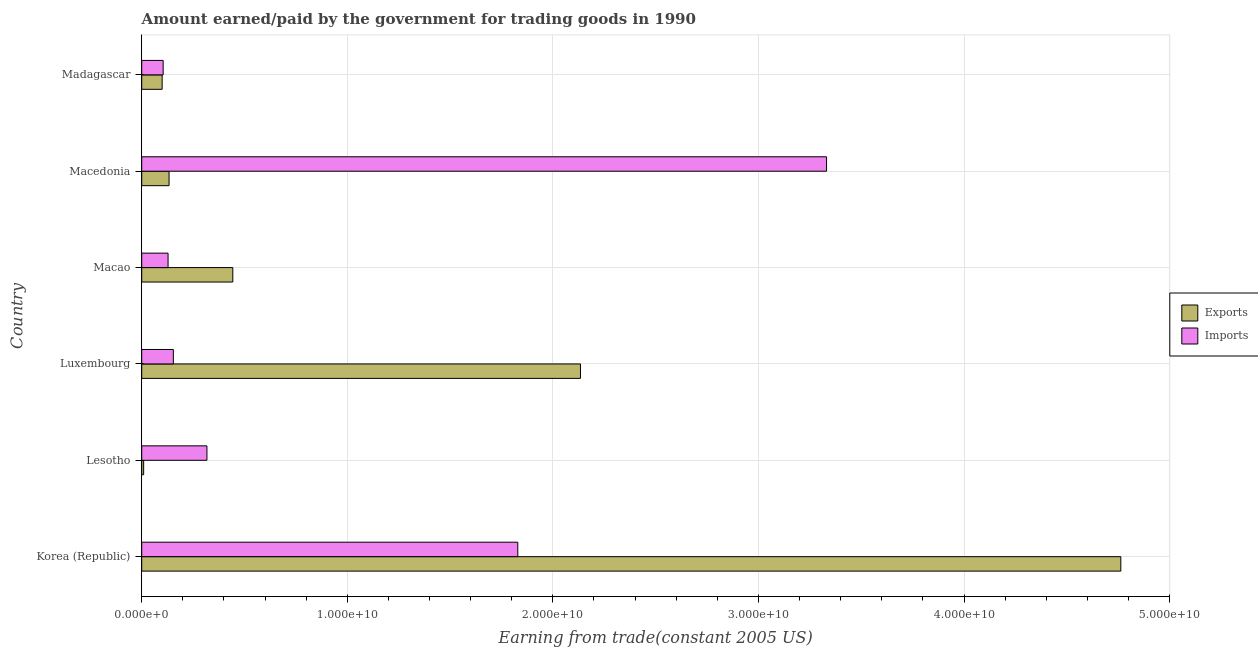How many different coloured bars are there?
Ensure brevity in your answer.  2. What is the label of the 5th group of bars from the top?
Make the answer very short. Lesotho. In how many cases, is the number of bars for a given country not equal to the number of legend labels?
Provide a short and direct response. 0. What is the amount earned from exports in Lesotho?
Offer a terse response. 9.39e+07. Across all countries, what is the maximum amount earned from exports?
Ensure brevity in your answer.  4.76e+1. Across all countries, what is the minimum amount paid for imports?
Keep it short and to the point. 1.04e+09. In which country was the amount earned from exports minimum?
Your answer should be very brief. Lesotho. What is the total amount paid for imports in the graph?
Your answer should be very brief. 5.86e+1. What is the difference between the amount paid for imports in Luxembourg and that in Macedonia?
Give a very brief answer. -3.18e+1. What is the difference between the amount paid for imports in Korea (Republic) and the amount earned from exports in Macao?
Your answer should be very brief. 1.39e+1. What is the average amount earned from exports per country?
Keep it short and to the point. 1.26e+1. What is the difference between the amount earned from exports and amount paid for imports in Luxembourg?
Offer a terse response. 1.98e+1. What is the ratio of the amount paid for imports in Lesotho to that in Macedonia?
Your response must be concise. 0.1. Is the amount paid for imports in Luxembourg less than that in Macao?
Make the answer very short. No. Is the difference between the amount earned from exports in Lesotho and Macedonia greater than the difference between the amount paid for imports in Lesotho and Macedonia?
Provide a succinct answer. Yes. What is the difference between the highest and the second highest amount earned from exports?
Offer a terse response. 2.63e+1. What is the difference between the highest and the lowest amount earned from exports?
Your response must be concise. 4.75e+1. In how many countries, is the amount earned from exports greater than the average amount earned from exports taken over all countries?
Offer a terse response. 2. Is the sum of the amount earned from exports in Lesotho and Madagascar greater than the maximum amount paid for imports across all countries?
Offer a terse response. No. What does the 1st bar from the top in Korea (Republic) represents?
Offer a very short reply. Imports. What does the 1st bar from the bottom in Madagascar represents?
Keep it short and to the point. Exports. How many countries are there in the graph?
Provide a succinct answer. 6. Are the values on the major ticks of X-axis written in scientific E-notation?
Ensure brevity in your answer.  Yes. Does the graph contain any zero values?
Give a very brief answer. No. Does the graph contain grids?
Offer a very short reply. Yes. Where does the legend appear in the graph?
Give a very brief answer. Center right. How many legend labels are there?
Your answer should be very brief. 2. How are the legend labels stacked?
Provide a succinct answer. Vertical. What is the title of the graph?
Keep it short and to the point. Amount earned/paid by the government for trading goods in 1990. What is the label or title of the X-axis?
Give a very brief answer. Earning from trade(constant 2005 US). What is the label or title of the Y-axis?
Ensure brevity in your answer.  Country. What is the Earning from trade(constant 2005 US) of Exports in Korea (Republic)?
Your answer should be very brief. 4.76e+1. What is the Earning from trade(constant 2005 US) in Imports in Korea (Republic)?
Make the answer very short. 1.83e+1. What is the Earning from trade(constant 2005 US) in Exports in Lesotho?
Ensure brevity in your answer.  9.39e+07. What is the Earning from trade(constant 2005 US) in Imports in Lesotho?
Provide a succinct answer. 3.17e+09. What is the Earning from trade(constant 2005 US) in Exports in Luxembourg?
Your answer should be very brief. 2.13e+1. What is the Earning from trade(constant 2005 US) in Imports in Luxembourg?
Your response must be concise. 1.54e+09. What is the Earning from trade(constant 2005 US) of Exports in Macao?
Your answer should be compact. 4.43e+09. What is the Earning from trade(constant 2005 US) of Imports in Macao?
Offer a very short reply. 1.28e+09. What is the Earning from trade(constant 2005 US) in Exports in Macedonia?
Make the answer very short. 1.33e+09. What is the Earning from trade(constant 2005 US) in Imports in Macedonia?
Offer a very short reply. 3.33e+1. What is the Earning from trade(constant 2005 US) of Exports in Madagascar?
Offer a terse response. 9.93e+08. What is the Earning from trade(constant 2005 US) of Imports in Madagascar?
Provide a succinct answer. 1.04e+09. Across all countries, what is the maximum Earning from trade(constant 2005 US) in Exports?
Keep it short and to the point. 4.76e+1. Across all countries, what is the maximum Earning from trade(constant 2005 US) in Imports?
Make the answer very short. 3.33e+1. Across all countries, what is the minimum Earning from trade(constant 2005 US) in Exports?
Give a very brief answer. 9.39e+07. Across all countries, what is the minimum Earning from trade(constant 2005 US) in Imports?
Offer a very short reply. 1.04e+09. What is the total Earning from trade(constant 2005 US) in Exports in the graph?
Make the answer very short. 7.58e+1. What is the total Earning from trade(constant 2005 US) in Imports in the graph?
Provide a succinct answer. 5.86e+1. What is the difference between the Earning from trade(constant 2005 US) in Exports in Korea (Republic) and that in Lesotho?
Offer a terse response. 4.75e+1. What is the difference between the Earning from trade(constant 2005 US) of Imports in Korea (Republic) and that in Lesotho?
Ensure brevity in your answer.  1.51e+1. What is the difference between the Earning from trade(constant 2005 US) in Exports in Korea (Republic) and that in Luxembourg?
Keep it short and to the point. 2.63e+1. What is the difference between the Earning from trade(constant 2005 US) in Imports in Korea (Republic) and that in Luxembourg?
Your answer should be very brief. 1.68e+1. What is the difference between the Earning from trade(constant 2005 US) of Exports in Korea (Republic) and that in Macao?
Offer a very short reply. 4.32e+1. What is the difference between the Earning from trade(constant 2005 US) of Imports in Korea (Republic) and that in Macao?
Your answer should be compact. 1.70e+1. What is the difference between the Earning from trade(constant 2005 US) of Exports in Korea (Republic) and that in Macedonia?
Offer a very short reply. 4.63e+1. What is the difference between the Earning from trade(constant 2005 US) of Imports in Korea (Republic) and that in Macedonia?
Provide a short and direct response. -1.50e+1. What is the difference between the Earning from trade(constant 2005 US) in Exports in Korea (Republic) and that in Madagascar?
Your response must be concise. 4.66e+1. What is the difference between the Earning from trade(constant 2005 US) of Imports in Korea (Republic) and that in Madagascar?
Ensure brevity in your answer.  1.73e+1. What is the difference between the Earning from trade(constant 2005 US) in Exports in Lesotho and that in Luxembourg?
Your answer should be very brief. -2.12e+1. What is the difference between the Earning from trade(constant 2005 US) of Imports in Lesotho and that in Luxembourg?
Ensure brevity in your answer.  1.63e+09. What is the difference between the Earning from trade(constant 2005 US) in Exports in Lesotho and that in Macao?
Offer a very short reply. -4.34e+09. What is the difference between the Earning from trade(constant 2005 US) of Imports in Lesotho and that in Macao?
Your answer should be very brief. 1.89e+09. What is the difference between the Earning from trade(constant 2005 US) in Exports in Lesotho and that in Macedonia?
Offer a very short reply. -1.24e+09. What is the difference between the Earning from trade(constant 2005 US) in Imports in Lesotho and that in Macedonia?
Your answer should be compact. -3.01e+1. What is the difference between the Earning from trade(constant 2005 US) in Exports in Lesotho and that in Madagascar?
Offer a terse response. -8.99e+08. What is the difference between the Earning from trade(constant 2005 US) in Imports in Lesotho and that in Madagascar?
Offer a very short reply. 2.13e+09. What is the difference between the Earning from trade(constant 2005 US) of Exports in Luxembourg and that in Macao?
Provide a short and direct response. 1.69e+1. What is the difference between the Earning from trade(constant 2005 US) of Imports in Luxembourg and that in Macao?
Offer a terse response. 2.57e+08. What is the difference between the Earning from trade(constant 2005 US) in Exports in Luxembourg and that in Macedonia?
Give a very brief answer. 2.00e+1. What is the difference between the Earning from trade(constant 2005 US) in Imports in Luxembourg and that in Macedonia?
Offer a very short reply. -3.18e+1. What is the difference between the Earning from trade(constant 2005 US) of Exports in Luxembourg and that in Madagascar?
Your answer should be compact. 2.03e+1. What is the difference between the Earning from trade(constant 2005 US) of Imports in Luxembourg and that in Madagascar?
Provide a succinct answer. 4.95e+08. What is the difference between the Earning from trade(constant 2005 US) of Exports in Macao and that in Macedonia?
Your response must be concise. 3.10e+09. What is the difference between the Earning from trade(constant 2005 US) in Imports in Macao and that in Macedonia?
Ensure brevity in your answer.  -3.20e+1. What is the difference between the Earning from trade(constant 2005 US) in Exports in Macao and that in Madagascar?
Keep it short and to the point. 3.44e+09. What is the difference between the Earning from trade(constant 2005 US) in Imports in Macao and that in Madagascar?
Keep it short and to the point. 2.39e+08. What is the difference between the Earning from trade(constant 2005 US) of Exports in Macedonia and that in Madagascar?
Give a very brief answer. 3.36e+08. What is the difference between the Earning from trade(constant 2005 US) of Imports in Macedonia and that in Madagascar?
Your answer should be compact. 3.23e+1. What is the difference between the Earning from trade(constant 2005 US) of Exports in Korea (Republic) and the Earning from trade(constant 2005 US) of Imports in Lesotho?
Ensure brevity in your answer.  4.45e+1. What is the difference between the Earning from trade(constant 2005 US) of Exports in Korea (Republic) and the Earning from trade(constant 2005 US) of Imports in Luxembourg?
Give a very brief answer. 4.61e+1. What is the difference between the Earning from trade(constant 2005 US) in Exports in Korea (Republic) and the Earning from trade(constant 2005 US) in Imports in Macao?
Make the answer very short. 4.63e+1. What is the difference between the Earning from trade(constant 2005 US) of Exports in Korea (Republic) and the Earning from trade(constant 2005 US) of Imports in Macedonia?
Offer a very short reply. 1.43e+1. What is the difference between the Earning from trade(constant 2005 US) of Exports in Korea (Republic) and the Earning from trade(constant 2005 US) of Imports in Madagascar?
Offer a very short reply. 4.66e+1. What is the difference between the Earning from trade(constant 2005 US) of Exports in Lesotho and the Earning from trade(constant 2005 US) of Imports in Luxembourg?
Give a very brief answer. -1.44e+09. What is the difference between the Earning from trade(constant 2005 US) in Exports in Lesotho and the Earning from trade(constant 2005 US) in Imports in Macao?
Your response must be concise. -1.19e+09. What is the difference between the Earning from trade(constant 2005 US) of Exports in Lesotho and the Earning from trade(constant 2005 US) of Imports in Macedonia?
Offer a terse response. -3.32e+1. What is the difference between the Earning from trade(constant 2005 US) of Exports in Lesotho and the Earning from trade(constant 2005 US) of Imports in Madagascar?
Ensure brevity in your answer.  -9.49e+08. What is the difference between the Earning from trade(constant 2005 US) of Exports in Luxembourg and the Earning from trade(constant 2005 US) of Imports in Macao?
Keep it short and to the point. 2.01e+1. What is the difference between the Earning from trade(constant 2005 US) of Exports in Luxembourg and the Earning from trade(constant 2005 US) of Imports in Macedonia?
Provide a short and direct response. -1.20e+1. What is the difference between the Earning from trade(constant 2005 US) of Exports in Luxembourg and the Earning from trade(constant 2005 US) of Imports in Madagascar?
Give a very brief answer. 2.03e+1. What is the difference between the Earning from trade(constant 2005 US) of Exports in Macao and the Earning from trade(constant 2005 US) of Imports in Macedonia?
Your answer should be compact. -2.89e+1. What is the difference between the Earning from trade(constant 2005 US) of Exports in Macao and the Earning from trade(constant 2005 US) of Imports in Madagascar?
Your answer should be very brief. 3.39e+09. What is the difference between the Earning from trade(constant 2005 US) of Exports in Macedonia and the Earning from trade(constant 2005 US) of Imports in Madagascar?
Your answer should be very brief. 2.87e+08. What is the average Earning from trade(constant 2005 US) in Exports per country?
Offer a very short reply. 1.26e+1. What is the average Earning from trade(constant 2005 US) of Imports per country?
Provide a succinct answer. 9.77e+09. What is the difference between the Earning from trade(constant 2005 US) of Exports and Earning from trade(constant 2005 US) of Imports in Korea (Republic)?
Your response must be concise. 2.93e+1. What is the difference between the Earning from trade(constant 2005 US) in Exports and Earning from trade(constant 2005 US) in Imports in Lesotho?
Your response must be concise. -3.08e+09. What is the difference between the Earning from trade(constant 2005 US) of Exports and Earning from trade(constant 2005 US) of Imports in Luxembourg?
Offer a very short reply. 1.98e+1. What is the difference between the Earning from trade(constant 2005 US) in Exports and Earning from trade(constant 2005 US) in Imports in Macao?
Give a very brief answer. 3.15e+09. What is the difference between the Earning from trade(constant 2005 US) of Exports and Earning from trade(constant 2005 US) of Imports in Macedonia?
Provide a succinct answer. -3.20e+1. What is the difference between the Earning from trade(constant 2005 US) in Exports and Earning from trade(constant 2005 US) in Imports in Madagascar?
Make the answer very short. -4.94e+07. What is the ratio of the Earning from trade(constant 2005 US) of Exports in Korea (Republic) to that in Lesotho?
Give a very brief answer. 506.97. What is the ratio of the Earning from trade(constant 2005 US) of Imports in Korea (Republic) to that in Lesotho?
Make the answer very short. 5.77. What is the ratio of the Earning from trade(constant 2005 US) in Exports in Korea (Republic) to that in Luxembourg?
Provide a succinct answer. 2.23. What is the ratio of the Earning from trade(constant 2005 US) in Imports in Korea (Republic) to that in Luxembourg?
Keep it short and to the point. 11.89. What is the ratio of the Earning from trade(constant 2005 US) in Exports in Korea (Republic) to that in Macao?
Your answer should be compact. 10.75. What is the ratio of the Earning from trade(constant 2005 US) in Imports in Korea (Republic) to that in Macao?
Your answer should be compact. 14.27. What is the ratio of the Earning from trade(constant 2005 US) in Exports in Korea (Republic) to that in Macedonia?
Give a very brief answer. 35.82. What is the ratio of the Earning from trade(constant 2005 US) in Imports in Korea (Republic) to that in Macedonia?
Make the answer very short. 0.55. What is the ratio of the Earning from trade(constant 2005 US) in Exports in Korea (Republic) to that in Madagascar?
Offer a very short reply. 47.95. What is the ratio of the Earning from trade(constant 2005 US) of Imports in Korea (Republic) to that in Madagascar?
Keep it short and to the point. 17.55. What is the ratio of the Earning from trade(constant 2005 US) of Exports in Lesotho to that in Luxembourg?
Offer a very short reply. 0. What is the ratio of the Earning from trade(constant 2005 US) of Imports in Lesotho to that in Luxembourg?
Provide a short and direct response. 2.06. What is the ratio of the Earning from trade(constant 2005 US) in Exports in Lesotho to that in Macao?
Give a very brief answer. 0.02. What is the ratio of the Earning from trade(constant 2005 US) of Imports in Lesotho to that in Macao?
Ensure brevity in your answer.  2.48. What is the ratio of the Earning from trade(constant 2005 US) in Exports in Lesotho to that in Macedonia?
Ensure brevity in your answer.  0.07. What is the ratio of the Earning from trade(constant 2005 US) in Imports in Lesotho to that in Macedonia?
Give a very brief answer. 0.1. What is the ratio of the Earning from trade(constant 2005 US) of Exports in Lesotho to that in Madagascar?
Your answer should be compact. 0.09. What is the ratio of the Earning from trade(constant 2005 US) of Imports in Lesotho to that in Madagascar?
Provide a succinct answer. 3.04. What is the ratio of the Earning from trade(constant 2005 US) of Exports in Luxembourg to that in Macao?
Keep it short and to the point. 4.82. What is the ratio of the Earning from trade(constant 2005 US) of Imports in Luxembourg to that in Macao?
Your answer should be very brief. 1.2. What is the ratio of the Earning from trade(constant 2005 US) in Exports in Luxembourg to that in Macedonia?
Offer a terse response. 16.05. What is the ratio of the Earning from trade(constant 2005 US) of Imports in Luxembourg to that in Macedonia?
Keep it short and to the point. 0.05. What is the ratio of the Earning from trade(constant 2005 US) in Exports in Luxembourg to that in Madagascar?
Ensure brevity in your answer.  21.49. What is the ratio of the Earning from trade(constant 2005 US) in Imports in Luxembourg to that in Madagascar?
Offer a very short reply. 1.48. What is the ratio of the Earning from trade(constant 2005 US) in Exports in Macao to that in Macedonia?
Provide a short and direct response. 3.33. What is the ratio of the Earning from trade(constant 2005 US) in Imports in Macao to that in Macedonia?
Your answer should be compact. 0.04. What is the ratio of the Earning from trade(constant 2005 US) in Exports in Macao to that in Madagascar?
Make the answer very short. 4.46. What is the ratio of the Earning from trade(constant 2005 US) of Imports in Macao to that in Madagascar?
Provide a succinct answer. 1.23. What is the ratio of the Earning from trade(constant 2005 US) of Exports in Macedonia to that in Madagascar?
Ensure brevity in your answer.  1.34. What is the ratio of the Earning from trade(constant 2005 US) in Imports in Macedonia to that in Madagascar?
Offer a very short reply. 31.95. What is the difference between the highest and the second highest Earning from trade(constant 2005 US) in Exports?
Make the answer very short. 2.63e+1. What is the difference between the highest and the second highest Earning from trade(constant 2005 US) in Imports?
Your answer should be compact. 1.50e+1. What is the difference between the highest and the lowest Earning from trade(constant 2005 US) in Exports?
Ensure brevity in your answer.  4.75e+1. What is the difference between the highest and the lowest Earning from trade(constant 2005 US) of Imports?
Offer a terse response. 3.23e+1. 